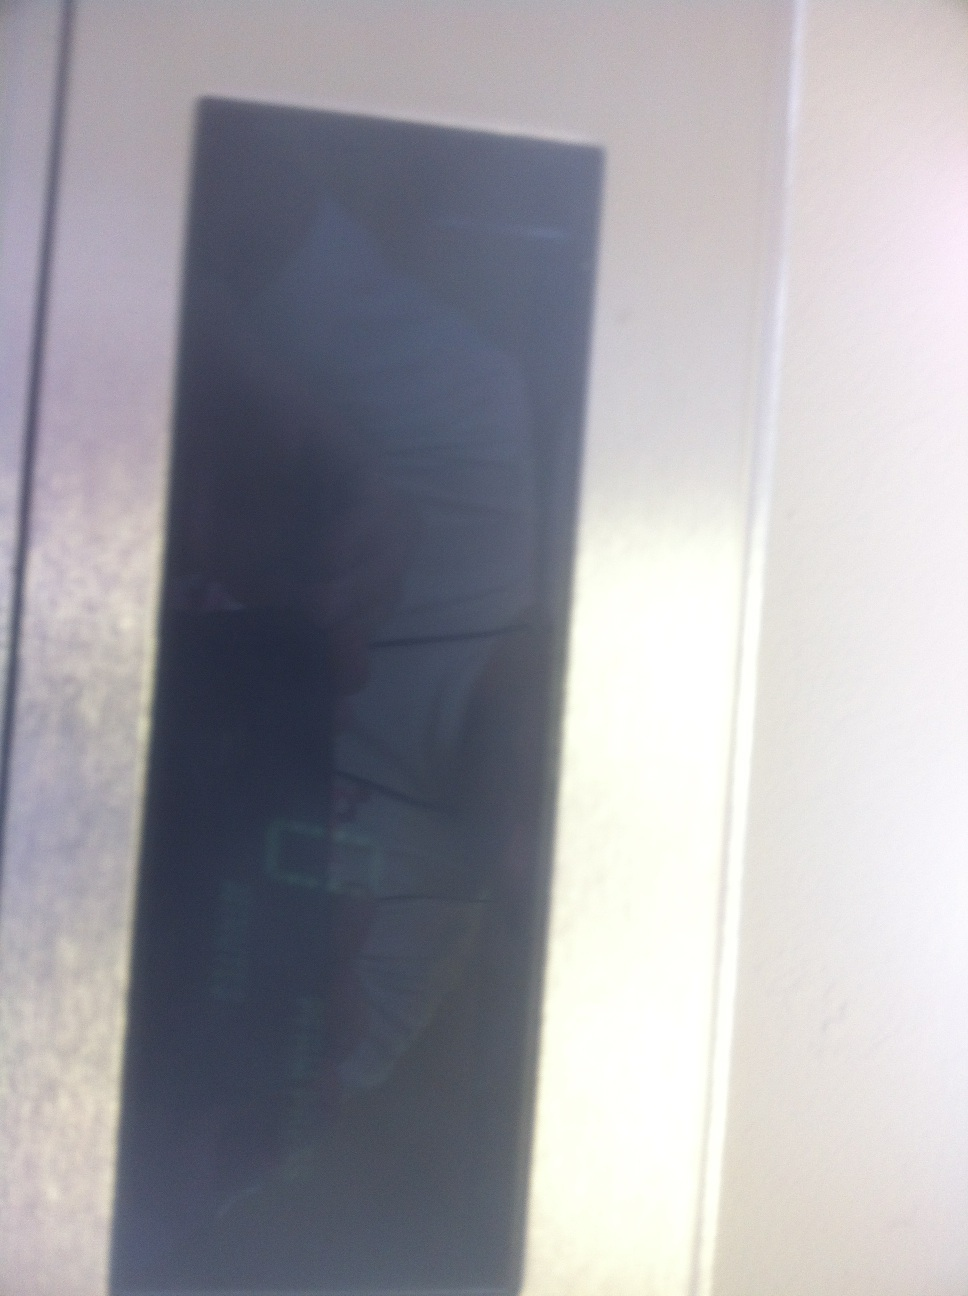Describe a futuristic scenario where this display is used in a smart home environment. In a futuristic smart home, this display could be integrated into a central control panel in the living room. It would manage all house systems, from climate control to security and entertainment. For example, with a touch or voice command, the homeowner could adjust the room temperature, check energy consumption, view security camera feeds, or even control the lighting ambiance for different moods. The display could also provide alerts and notifications about upcoming appointments, weather updates, or deliveries, making the home more efficient and connected. 